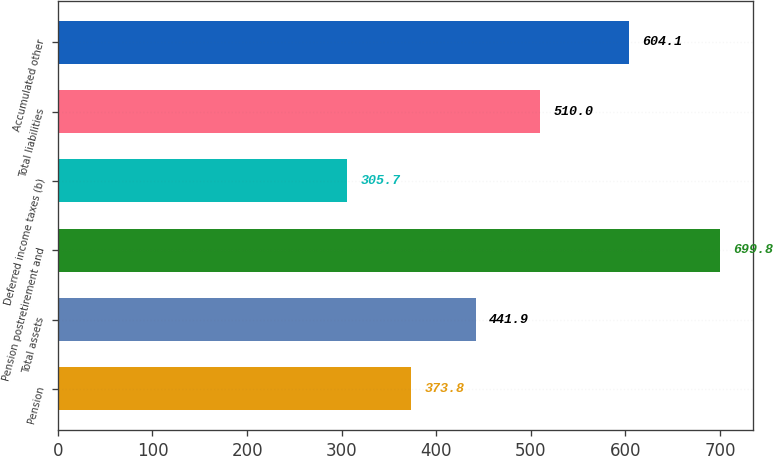<chart> <loc_0><loc_0><loc_500><loc_500><bar_chart><fcel>Pension<fcel>Total assets<fcel>Pension postretirement and<fcel>Deferred income taxes (b)<fcel>Total liabilities<fcel>Accumulated other<nl><fcel>373.8<fcel>441.9<fcel>699.8<fcel>305.7<fcel>510<fcel>604.1<nl></chart> 